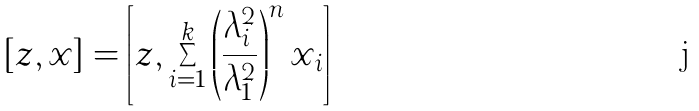<formula> <loc_0><loc_0><loc_500><loc_500>[ z , x ] = \left [ z , \sum _ { i = 1 } ^ { k } \left ( \frac { \lambda _ { i } ^ { 2 } } { \lambda _ { 1 } ^ { 2 } } \right ) ^ { n } x _ { i } \right ]</formula> 